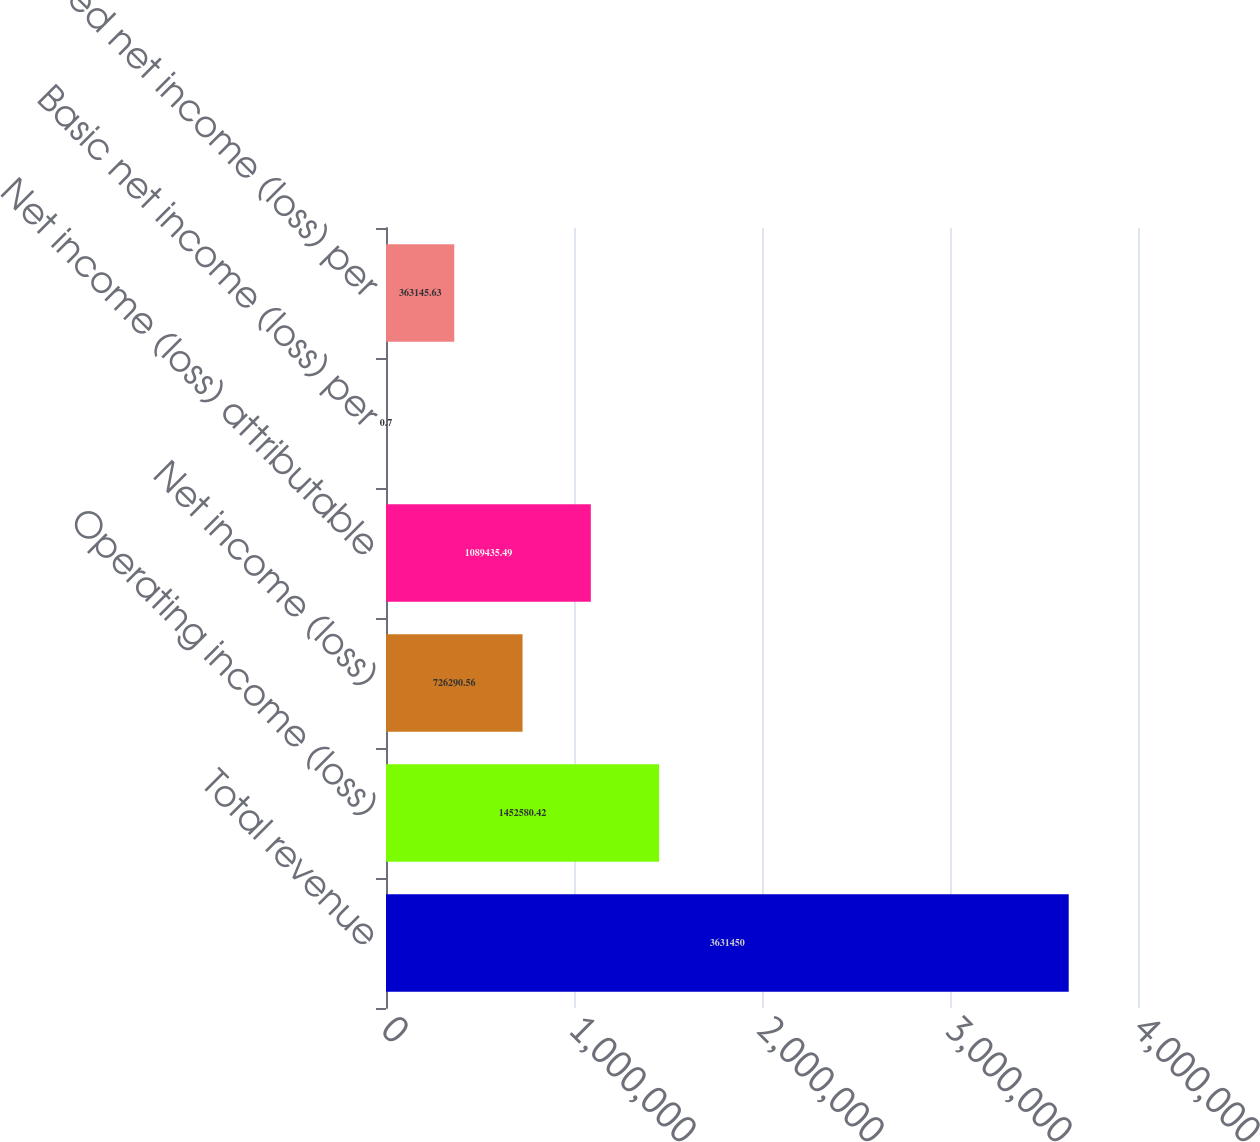Convert chart to OTSL. <chart><loc_0><loc_0><loc_500><loc_500><bar_chart><fcel>Total revenue<fcel>Operating income (loss)<fcel>Net income (loss)<fcel>Net income (loss) attributable<fcel>Basic net income (loss) per<fcel>Diluted net income (loss) per<nl><fcel>3.63145e+06<fcel>1.45258e+06<fcel>726291<fcel>1.08944e+06<fcel>0.7<fcel>363146<nl></chart> 